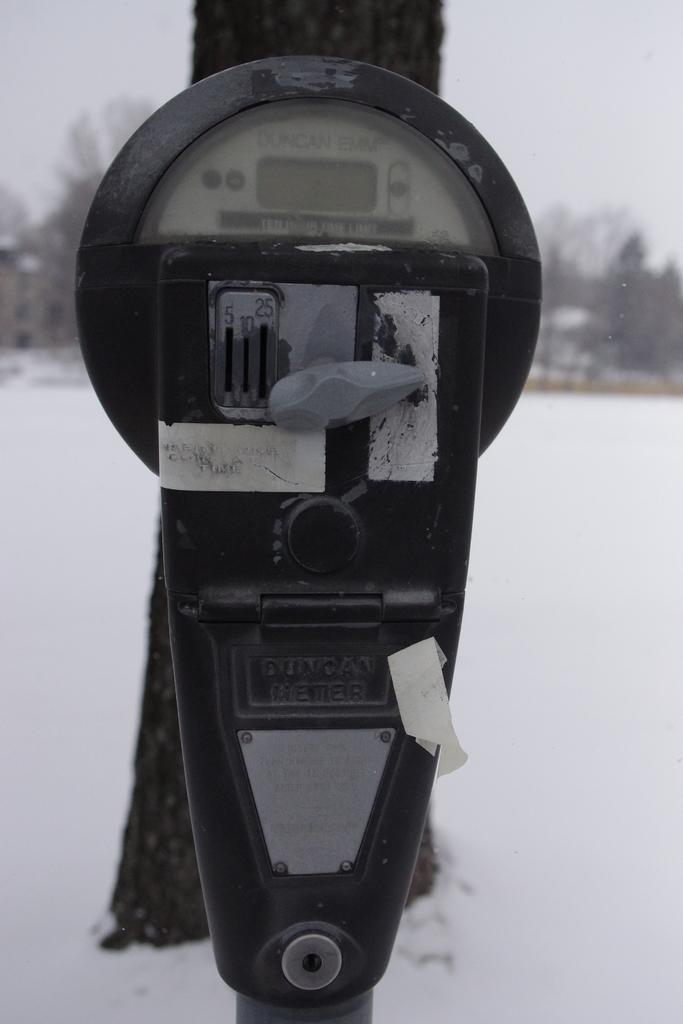What object can be seen on the side of the road in the image? There is a parking meter in the image. What is located on the snow surface in the image? There is a tree trunk on the snow surface in the image. What type of vegetation can be seen in the distance in the image? There are trees visible in the distance in the image. What part of the natural environment is visible in the distance in the image? The sky is visible in the distance in the image, but it is not clearly visible. How many pets are visible in the image? There are no pets present in the image. What type of help is the queen providing in the image? There is no queen or any indication of help being provided in the image. 